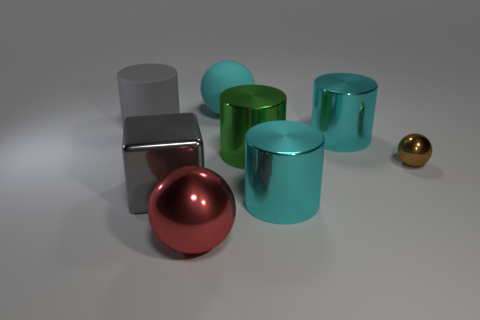Add 2 blocks. How many objects exist? 10 Subtract all cyan balls. How many balls are left? 2 Subtract all large spheres. How many spheres are left? 1 Subtract all cubes. How many objects are left? 7 Subtract 1 blocks. How many blocks are left? 0 Subtract all green spheres. Subtract all cyan blocks. How many spheres are left? 3 Subtract all brown spheres. How many blue blocks are left? 0 Subtract all large gray rubber cylinders. Subtract all big rubber cylinders. How many objects are left? 6 Add 6 tiny brown spheres. How many tiny brown spheres are left? 7 Add 8 rubber spheres. How many rubber spheres exist? 9 